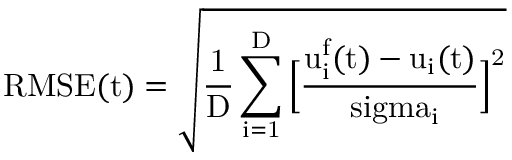Convert formula to latex. <formula><loc_0><loc_0><loc_500><loc_500>R M S E ( t ) = \sqrt { \frac { 1 } { D } \sum _ { i = 1 } ^ { D } \left [ \frac { u _ { i } ^ { f } ( t ) - u _ { i } ( t ) } { \ s i g m a _ { i } } \right ] ^ { 2 } }</formula> 